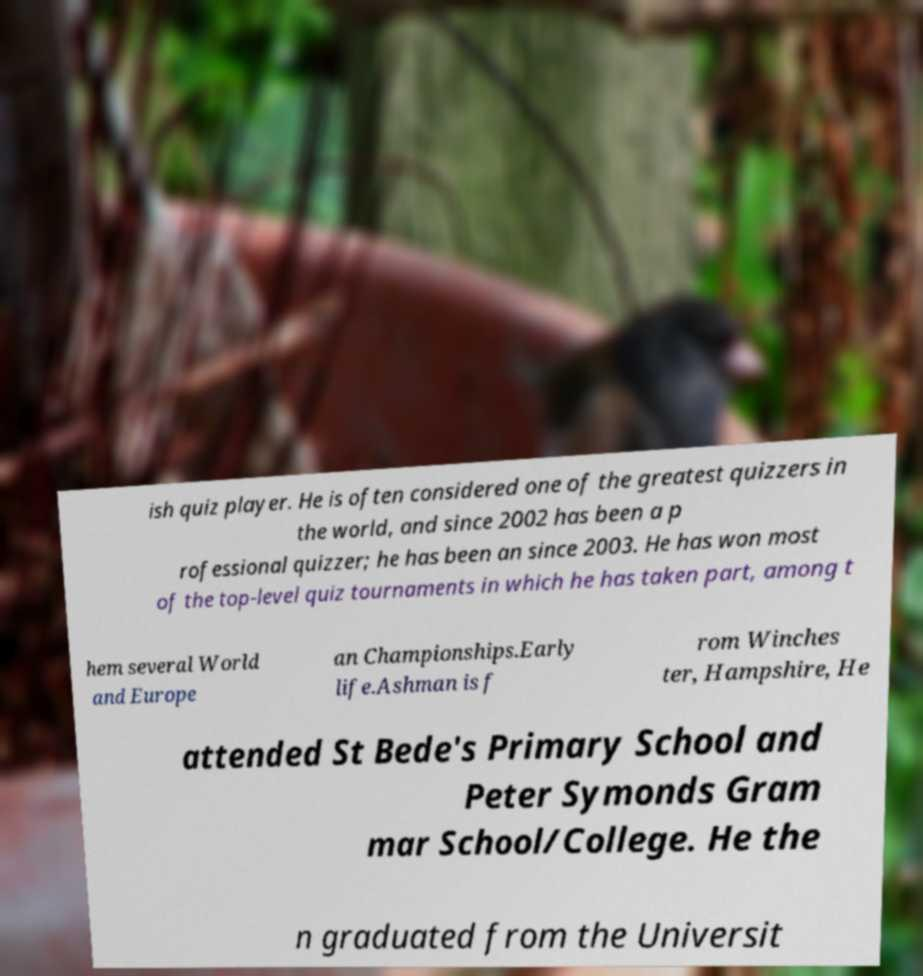Could you extract and type out the text from this image? ish quiz player. He is often considered one of the greatest quizzers in the world, and since 2002 has been a p rofessional quizzer; he has been an since 2003. He has won most of the top-level quiz tournaments in which he has taken part, among t hem several World and Europe an Championships.Early life.Ashman is f rom Winches ter, Hampshire, He attended St Bede's Primary School and Peter Symonds Gram mar School/College. He the n graduated from the Universit 